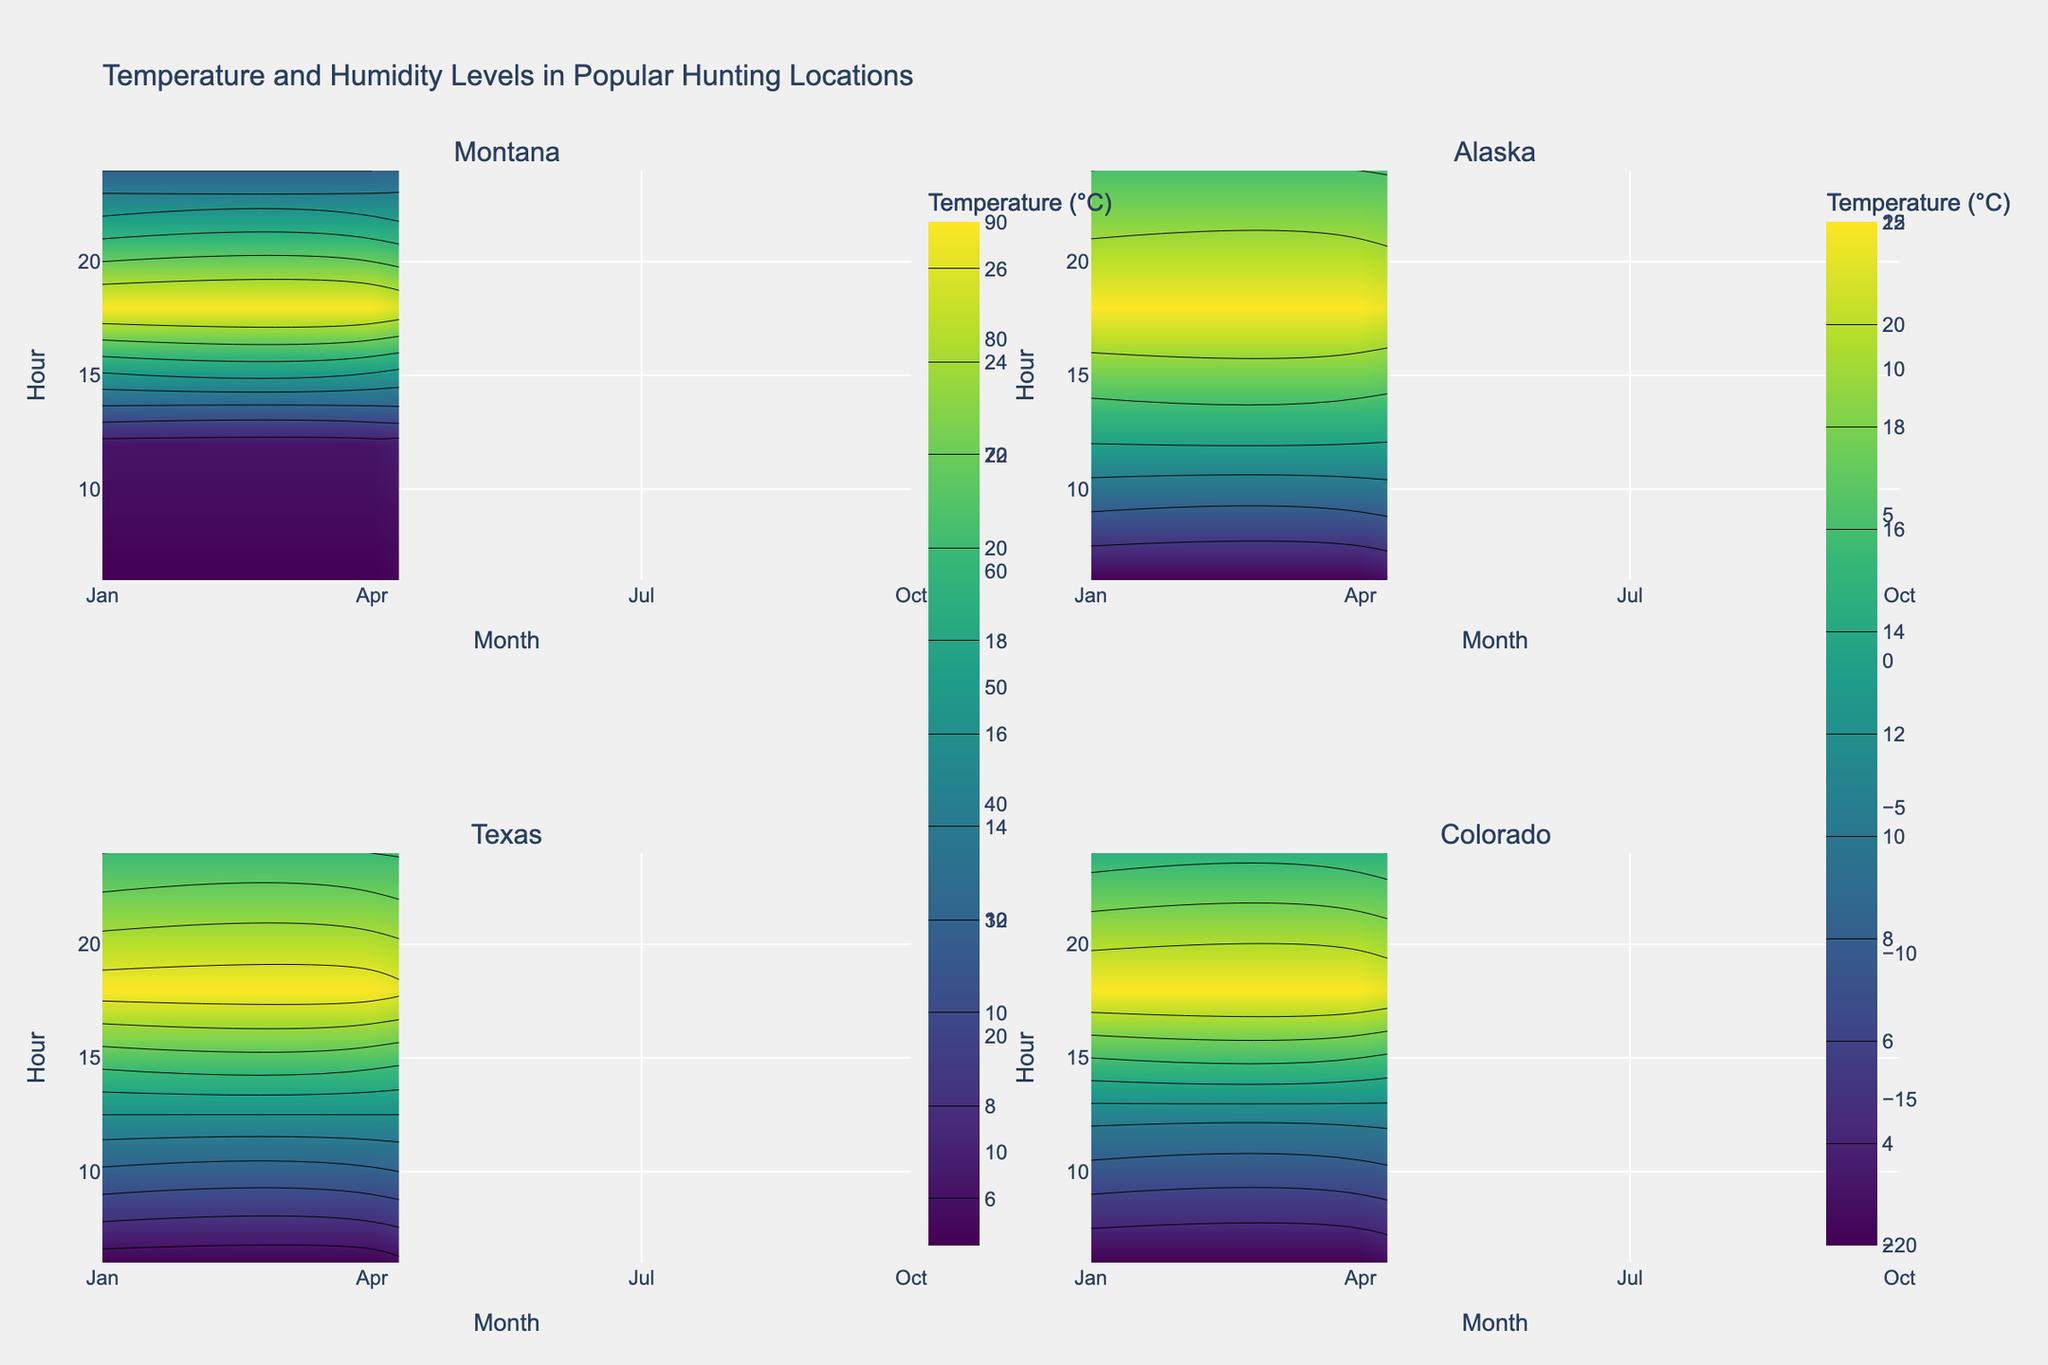Which location has the highest temperature during July at 6 AM? Check the subplot for each location and find the temperature contour for July at 6 AM. Montana has the highest temperature.
Answer: Montana What's the average humidity level in Texas for January at noon? Look at the contour for Texas in January at noon and add up the humidity levels from the temperature contour lines and divide by the number of data points. (35%)
Answer: 35 During which month does Colorado experience its lowest humidity at 6 AM? Compare the humidity levels at 6 AM across the four months in the Colorado subplot. The lowest humidity is in July.
Answer: July Which month in Alaska has the highest temperature at 6 AM? Check the temperature contours in Alaska at 6 AM across all months. July has the highest temperature.
Answer: July In Montana, how much does the humidity level change from 6 AM to noon in October? In the Montana subplot, look at the humidity levels in October and calculate the difference between 6 AM and noon. The change is (70 - 60 = 10%).
Answer: 10 How does the temperature in Texas differ between January and July at noon? Compare the temperature contours at noon for Texas in January and July. The difference is (27 - 5 = 22°C).
Answer: 22°C Which location has the smallest temperature fluctuation between 6 AM and noon across all months? Examine the temperature contours for each location and identify which one has the smallest difference between 6 AM and noon for all months combined. Texas has the smallest fluctuation.
Answer: Texas 